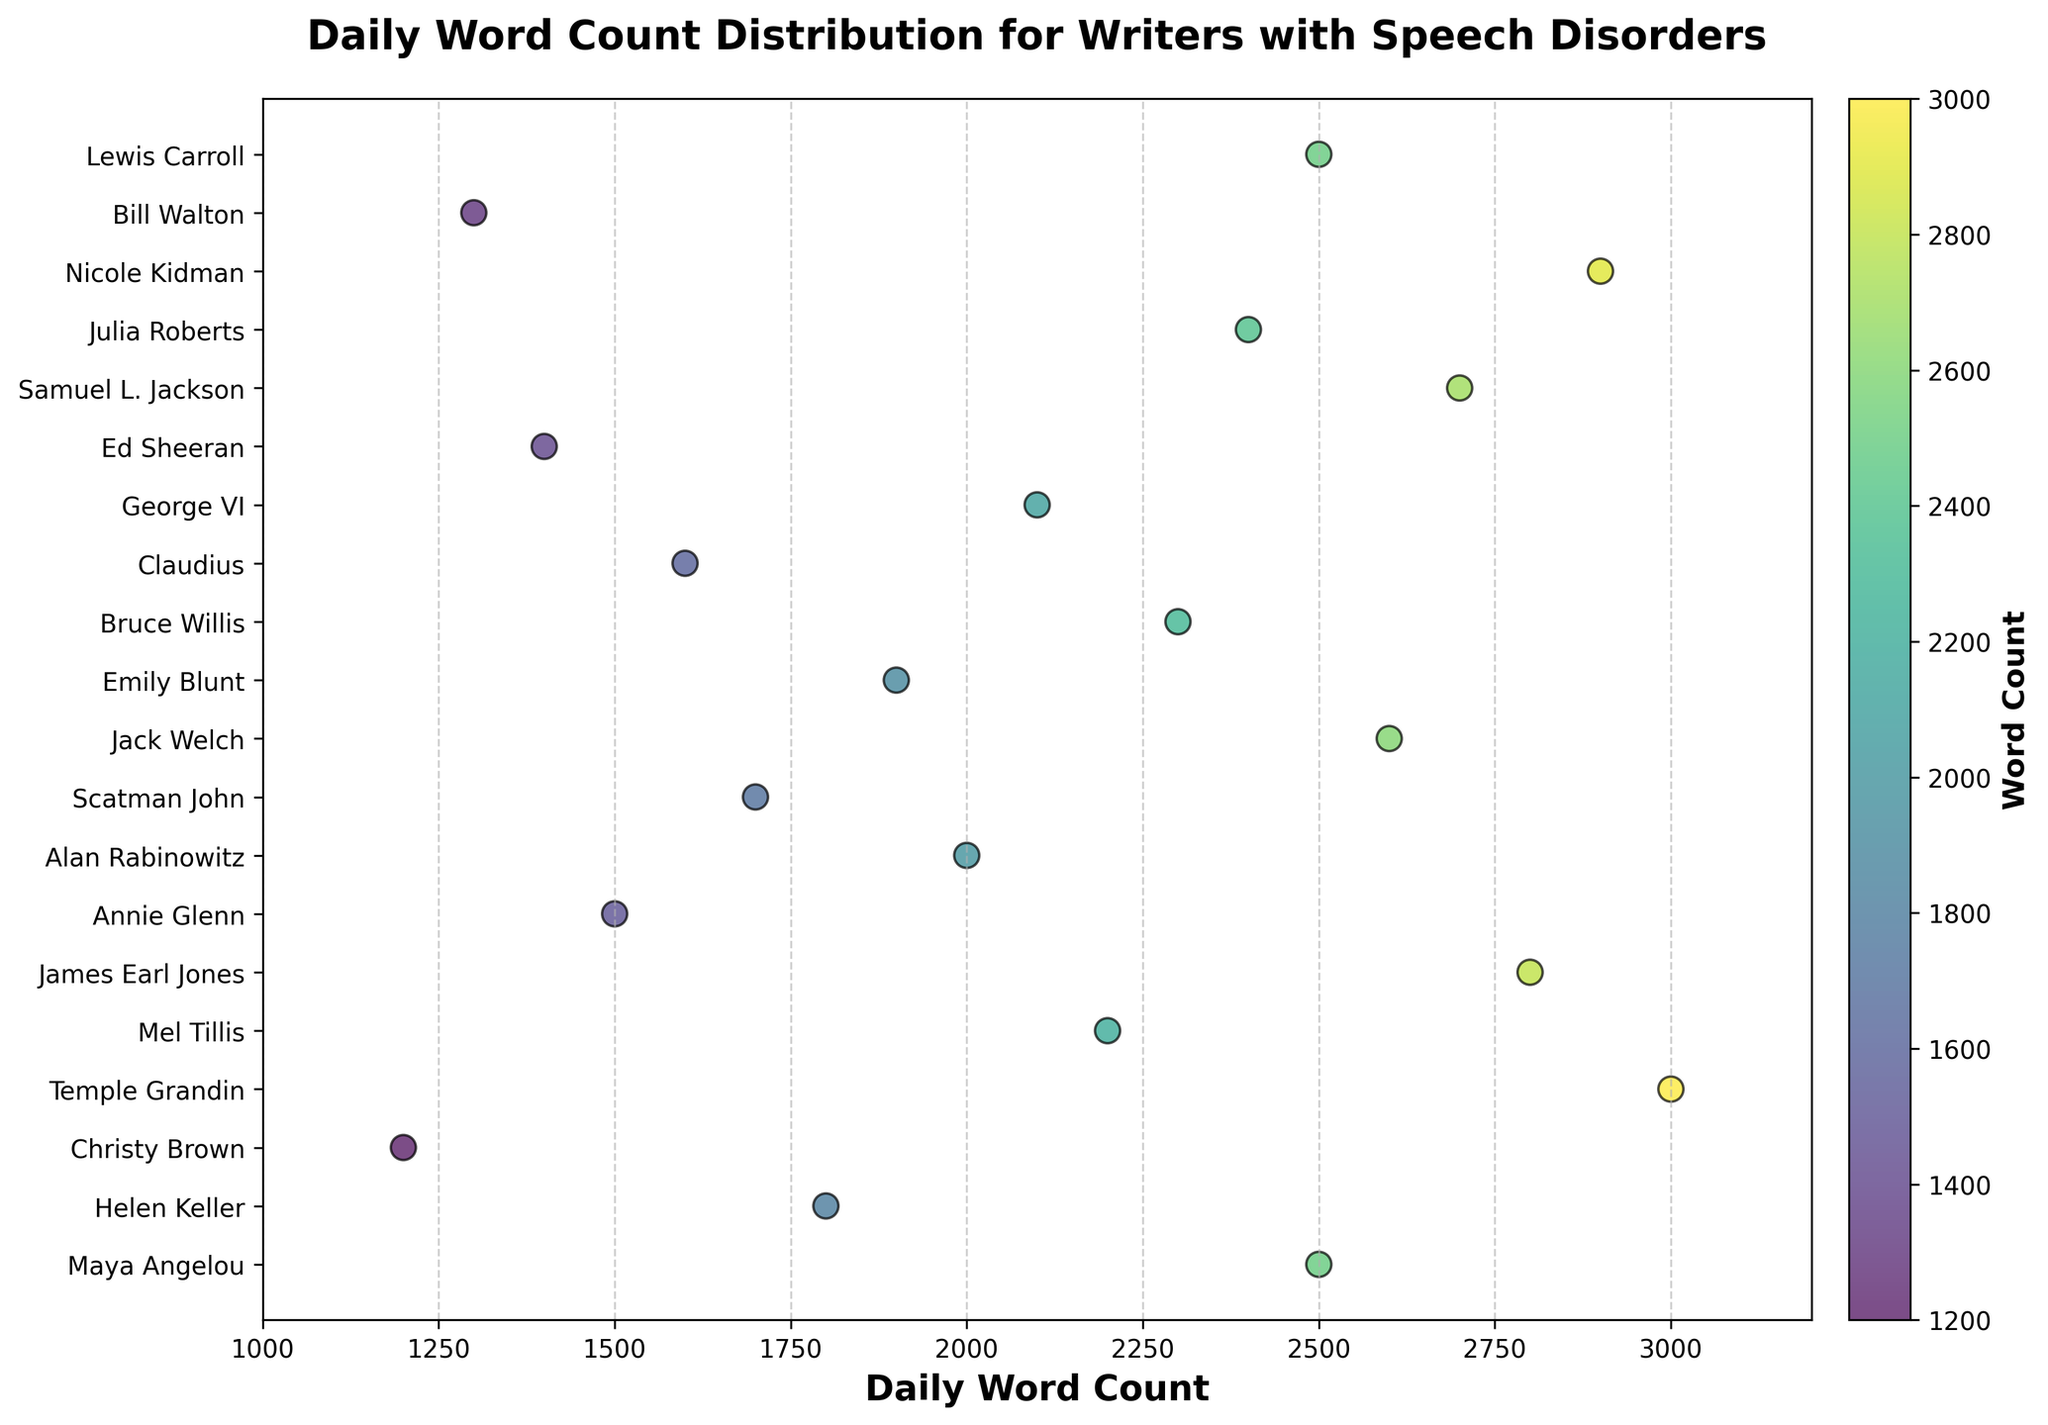What's the title of the figure? The title is the text displayed at the top of the plot. It describes what the figure is about.
Answer: Daily Word Count Distribution for Writers with Speech Disorders How many writers are included in the figure? Count the number of unique ticks on the y-axis, which corresponds to the number of writers.
Answer: 20 What is the range of daily word counts? Identify the smallest and largest values on the x-axis that the plot covers.
Answer: 1000 to 3200 Which writer has the highest daily word count? Find the point that is furthest to the right on the x-axis and check its corresponding y-axis label.
Answer: Temple Grandin Which two writers have daily word counts of 2500 words? Locate the points at 2500 on the x-axis and identify their corresponding y-axis labels.
Answer: Maya Angelou and Lewis Carroll What is the average daily word count of the writers? Add up all the daily word counts and divide by the number of writers (20). (2500 + 1800 + 1200 + 3000 + 2200 + 2800 + 1500 + 2000 + 1700 + 2600 + 1900 + 2300 + 1600 + 2100 + 1400 + 2700 + 2400 + 2900 + 1300 + 2500) / 20 = 2090
Answer: 2090 What is the color scheme used in the plot? Look at the color gradient used in the scatter plot, which generally represents a color map.
Answer: Viridis_color_map How does the color of the points vary with the word count? Observe the color gradient from lower to higher word counts. Darker colors likely represent lower values while brighter colors represent higher values.
Answer: Darker to brighter (low to high) Who has a daily word count closest to the average? First, calculate the average daily word count (2090), then check which writer's word count is nearest to this value on the x-axis.
Answer: George VI (2100) Which writers appear in the middle range of daily word counts (i.e., between 2000 and 2500)? Identify the writers whose daily word counts fall within the 2000-2500 range by referring to the points in this particular portion of the x-axis.
Answer: Alan Rabinowitz, Mel Tillis, George VI, Julia Roberts, Jack Welch 